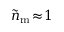<formula> <loc_0><loc_0><loc_500><loc_500>\widetilde { n } _ { m } \, \approx \, 1</formula> 